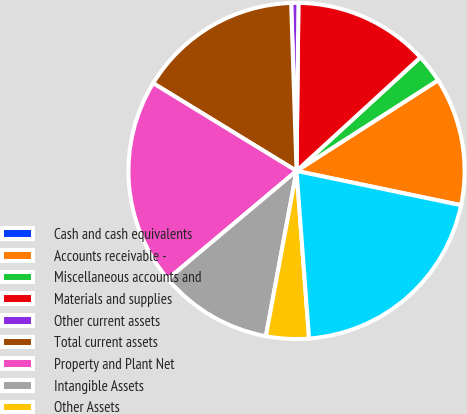Convert chart to OTSL. <chart><loc_0><loc_0><loc_500><loc_500><pie_chart><fcel>Cash and cash equivalents<fcel>Accounts receivable -<fcel>Miscellaneous accounts and<fcel>Materials and supplies<fcel>Other current assets<fcel>Total current assets<fcel>Property and Plant Net<fcel>Intangible Assets<fcel>Other Assets<fcel>TOTAL ASSETS<nl><fcel>0.01%<fcel>12.33%<fcel>2.74%<fcel>13.01%<fcel>0.69%<fcel>15.75%<fcel>19.86%<fcel>10.96%<fcel>4.11%<fcel>20.54%<nl></chart> 